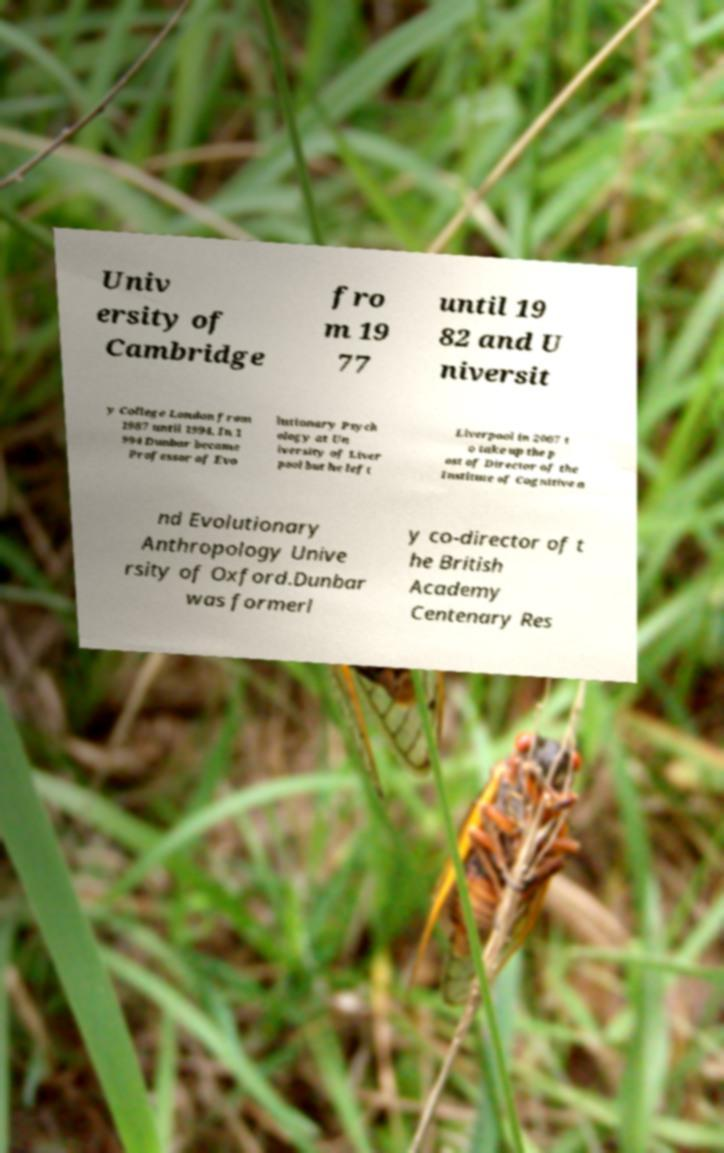Can you accurately transcribe the text from the provided image for me? Univ ersity of Cambridge fro m 19 77 until 19 82 and U niversit y College London from 1987 until 1994. In 1 994 Dunbar became Professor of Evo lutionary Psych ology at Un iversity of Liver pool but he left Liverpool in 2007 t o take up the p ost of Director of the Institute of Cognitive a nd Evolutionary Anthropology Unive rsity of Oxford.Dunbar was formerl y co-director of t he British Academy Centenary Res 